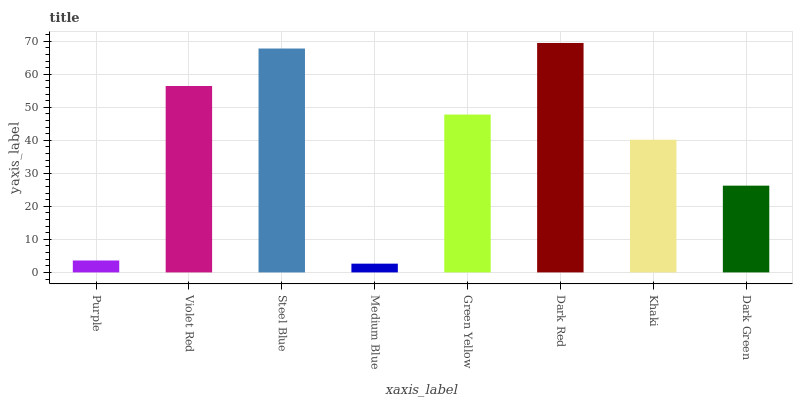Is Medium Blue the minimum?
Answer yes or no. Yes. Is Dark Red the maximum?
Answer yes or no. Yes. Is Violet Red the minimum?
Answer yes or no. No. Is Violet Red the maximum?
Answer yes or no. No. Is Violet Red greater than Purple?
Answer yes or no. Yes. Is Purple less than Violet Red?
Answer yes or no. Yes. Is Purple greater than Violet Red?
Answer yes or no. No. Is Violet Red less than Purple?
Answer yes or no. No. Is Green Yellow the high median?
Answer yes or no. Yes. Is Khaki the low median?
Answer yes or no. Yes. Is Violet Red the high median?
Answer yes or no. No. Is Dark Red the low median?
Answer yes or no. No. 